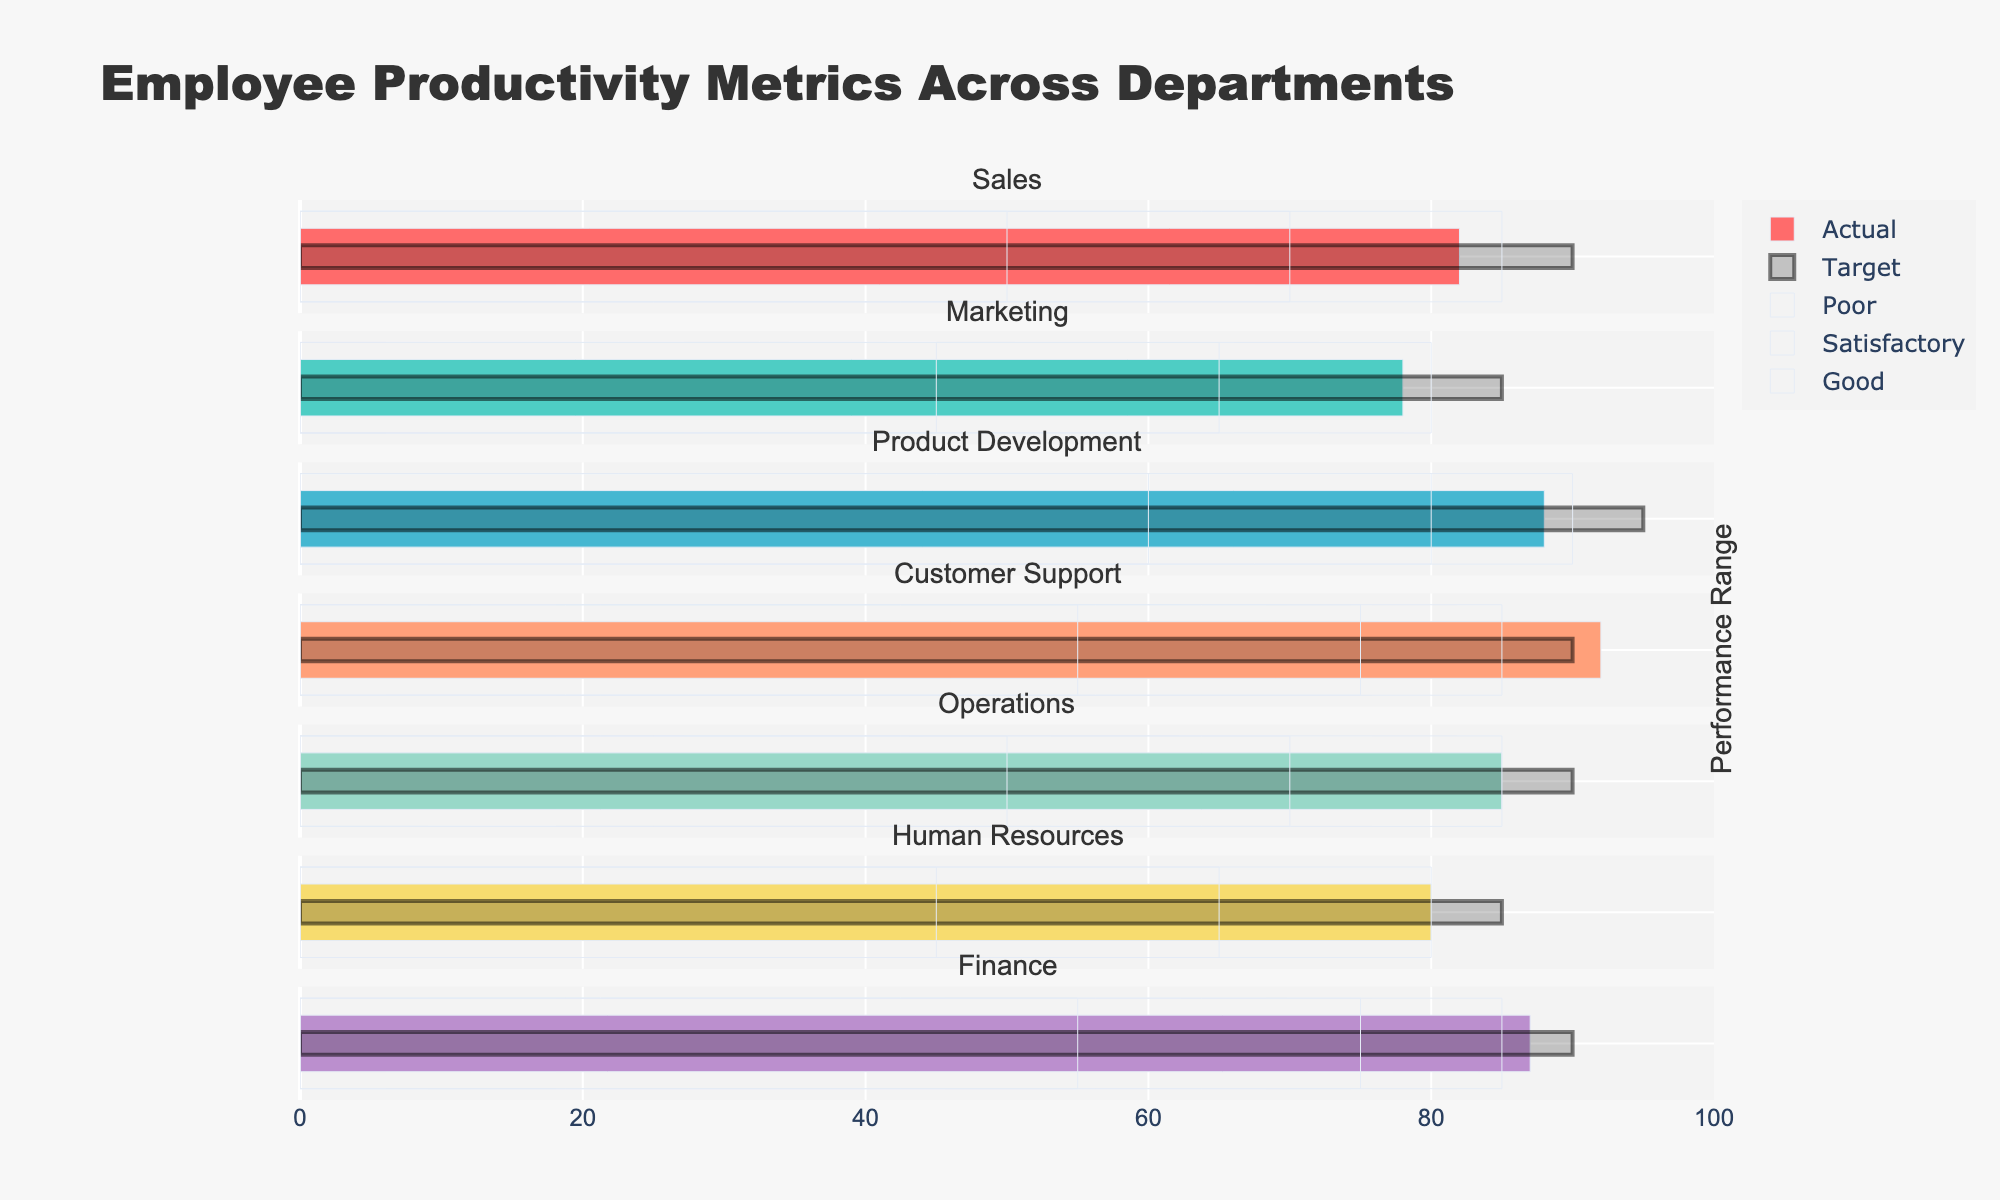Which department has the highest actual productivity? Look at the actual productivity bars and find the one with the highest value. Customer Support's actual productivity bar is 92, which is the highest.
Answer: Customer Support What's the target productivity for the Marketing department? Identify the target productivity bar for the Marketing department. The target productivity value for Marketing is 85.
Answer: 85 Which department's actual productivity falls short of its target productivity the most? Compare the difference between actual and target productivity for each department. Product Development has the highest difference with an actual of 88 and a target of 95. The difference is 7.
Answer: Product Development How many departments meet or exceed their target productivity? Compare actual productivity with target productivity for each department. Sales, Customer Support, Operations, and Finance meet or exceed their target productivity.
Answer: 4 What is the range of satisfactory productivity for the Product Development department? Identify the satisfactory range bar for the Product Development department. The range is from 60 to 80.
Answer: 60 to 80 Which department has the smallest gap between its actual and target productivity? Calculate the differences and find the smallest one. Customer Support's actual productivity is 92 and the target is 90. The difference is -2.
Answer: Customer Support Compare the actual productivity of the Sales and Operations departments. Which one is higher? Look at the actual productivity bars for both departments. Sales has an actual productivity of 82 and Operations has 85, making Operations higher.
Answer: Operations What is the average actual productivity of all departments? Add up the actual productivity values for all departments and divide by the number of departments. (82 + 78 + 88 + 92 + 85 + 80 + 87) / 7 = 84
Answer: 84 Which department falls within the 'Good' performance range? Observe which department's actual productivity falls in the 'Good' range bar. Customer Support falls within the 'Good' range with an actual value of 92, which is between 85 and 90.
Answer: Customer Support What is the color of the actual productivity bar for the Finance department? Identify the actual productivity bar color for the Finance department. The color of the actual productivity bar for Finance is purple.
Answer: purple 